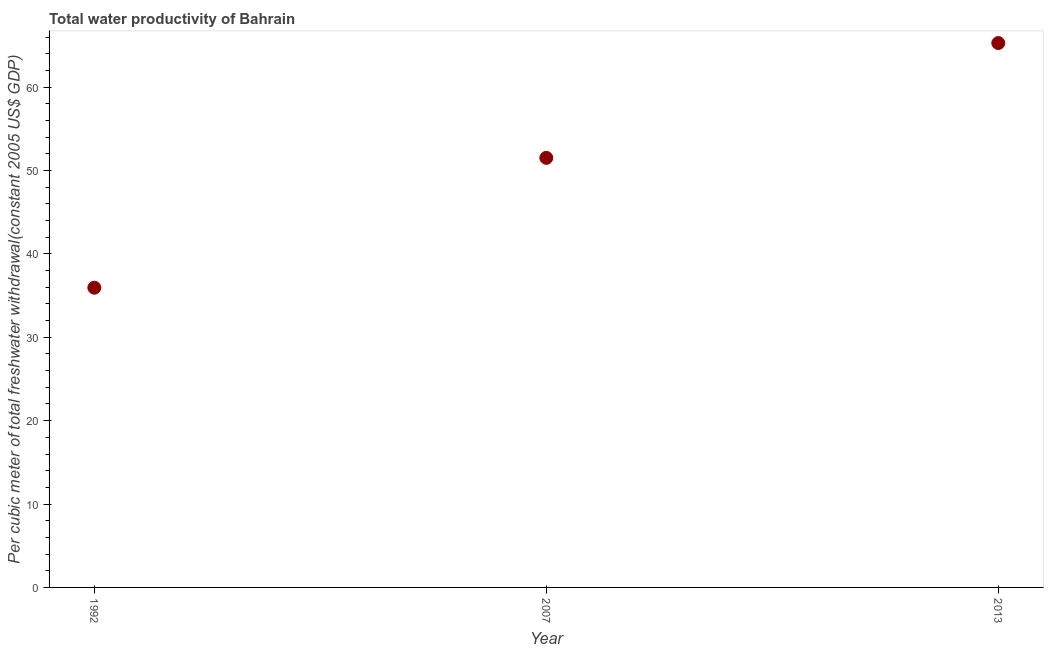What is the total water productivity in 1992?
Your response must be concise. 35.94. Across all years, what is the maximum total water productivity?
Give a very brief answer. 65.28. Across all years, what is the minimum total water productivity?
Your response must be concise. 35.94. What is the sum of the total water productivity?
Keep it short and to the point. 152.74. What is the difference between the total water productivity in 1992 and 2007?
Make the answer very short. -15.57. What is the average total water productivity per year?
Provide a succinct answer. 50.91. What is the median total water productivity?
Keep it short and to the point. 51.52. Do a majority of the years between 1992 and 2007 (inclusive) have total water productivity greater than 28 US$?
Provide a succinct answer. Yes. What is the ratio of the total water productivity in 1992 to that in 2013?
Provide a short and direct response. 0.55. Is the difference between the total water productivity in 1992 and 2007 greater than the difference between any two years?
Offer a very short reply. No. What is the difference between the highest and the second highest total water productivity?
Offer a terse response. 13.77. What is the difference between the highest and the lowest total water productivity?
Your answer should be compact. 29.34. In how many years, is the total water productivity greater than the average total water productivity taken over all years?
Provide a succinct answer. 2. What is the difference between two consecutive major ticks on the Y-axis?
Provide a short and direct response. 10. Does the graph contain any zero values?
Offer a very short reply. No. What is the title of the graph?
Your answer should be compact. Total water productivity of Bahrain. What is the label or title of the X-axis?
Make the answer very short. Year. What is the label or title of the Y-axis?
Your answer should be very brief. Per cubic meter of total freshwater withdrawal(constant 2005 US$ GDP). What is the Per cubic meter of total freshwater withdrawal(constant 2005 US$ GDP) in 1992?
Ensure brevity in your answer.  35.94. What is the Per cubic meter of total freshwater withdrawal(constant 2005 US$ GDP) in 2007?
Your response must be concise. 51.52. What is the Per cubic meter of total freshwater withdrawal(constant 2005 US$ GDP) in 2013?
Your response must be concise. 65.28. What is the difference between the Per cubic meter of total freshwater withdrawal(constant 2005 US$ GDP) in 1992 and 2007?
Provide a succinct answer. -15.57. What is the difference between the Per cubic meter of total freshwater withdrawal(constant 2005 US$ GDP) in 1992 and 2013?
Offer a very short reply. -29.34. What is the difference between the Per cubic meter of total freshwater withdrawal(constant 2005 US$ GDP) in 2007 and 2013?
Provide a short and direct response. -13.77. What is the ratio of the Per cubic meter of total freshwater withdrawal(constant 2005 US$ GDP) in 1992 to that in 2007?
Ensure brevity in your answer.  0.7. What is the ratio of the Per cubic meter of total freshwater withdrawal(constant 2005 US$ GDP) in 1992 to that in 2013?
Provide a short and direct response. 0.55. What is the ratio of the Per cubic meter of total freshwater withdrawal(constant 2005 US$ GDP) in 2007 to that in 2013?
Your answer should be compact. 0.79. 